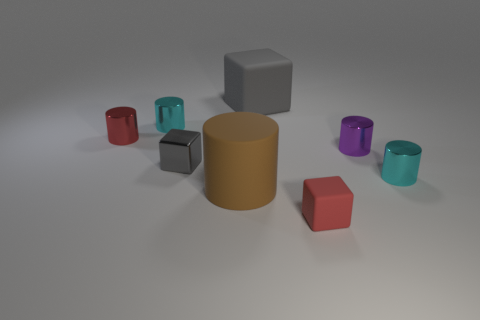Subtract all small rubber cubes. How many cubes are left? 2 Add 2 red rubber things. How many objects exist? 10 Subtract all blue spheres. How many gray blocks are left? 2 Subtract all cyan cylinders. How many cylinders are left? 3 Subtract all blocks. How many objects are left? 5 Subtract all cyan cubes. Subtract all green spheres. How many cubes are left? 3 Subtract all cyan cylinders. Subtract all purple cylinders. How many objects are left? 5 Add 2 large gray blocks. How many large gray blocks are left? 3 Add 6 brown rubber cylinders. How many brown rubber cylinders exist? 7 Subtract 0 brown balls. How many objects are left? 8 